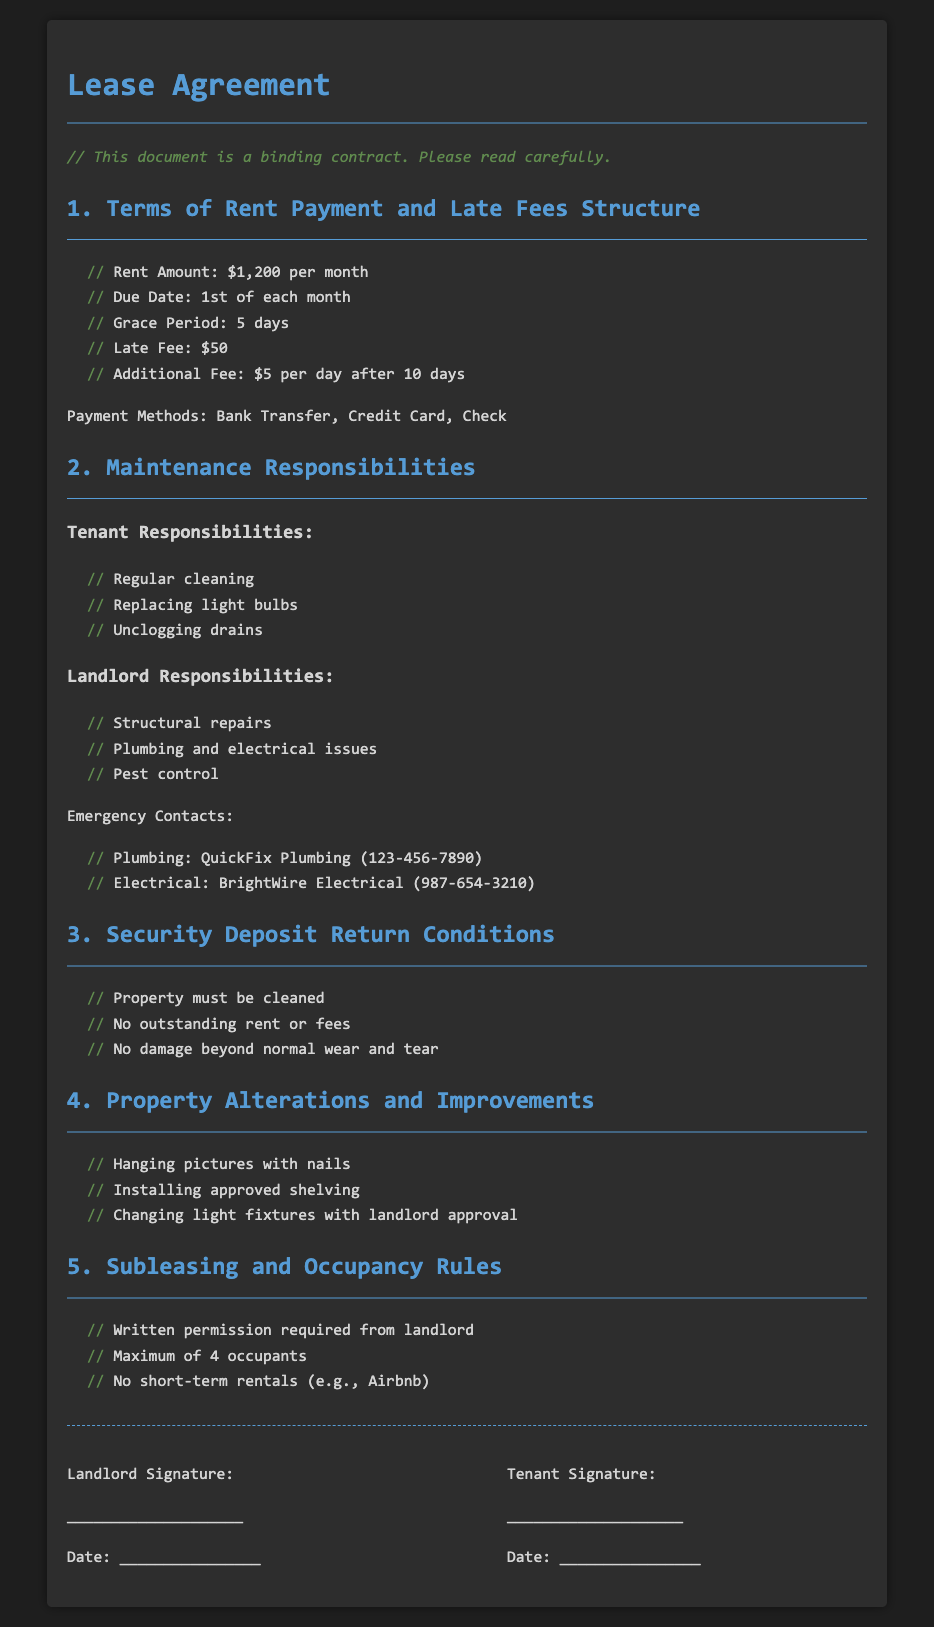what is the monthly rent amount? The rent amount is explicitly stated in the document as $1,200 per month.
Answer: $1,200 what is the late fee for overdue rent? The document specifies a late fee of $50 for overdue rent payments.
Answer: $50 how long is the grace period for rent payment? The grace period is mentioned to be 5 days after the due date.
Answer: 5 days who is responsible for structural repairs? The landlord is responsible for structural repairs, which is highlighted in the maintenance responsibilities section.
Answer: Landlord what must be completed for the security deposit to be returned? The document states that the property must be cleaned and no outstanding rent or fees are allowed for the security deposit to be returned.
Answer: Property must be cleaned what is the maximum number of occupants allowed? The lease agreement specifies that a maximum of 4 occupants is permitted in the property.
Answer: 4 occupants is written permission required for subleasing? The document clearly states that written permission from the landlord is required for subleasing the property.
Answer: Yes what type of property alterations are allowed? The agreement lists that hanging pictures with nails and installing approved shelving are permissible alterations.
Answer: Hanging pictures with nails what is the penalty for payments beyond 10 days late? The document specifies an additional fee of $5 per day for payments beyond 10 days late.
Answer: $5 per day who should be contacted for plumbing emergencies? The emergency contact for plumbing issues provided in the document is QuickFix Plumbing.
Answer: QuickFix Plumbing 